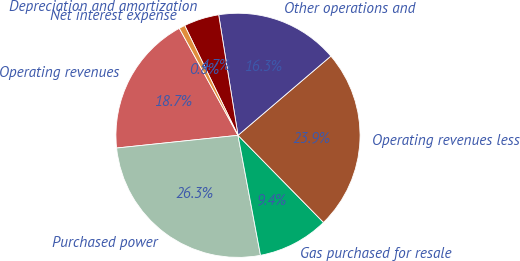Convert chart to OTSL. <chart><loc_0><loc_0><loc_500><loc_500><pie_chart><fcel>Operating revenues<fcel>Purchased power<fcel>Gas purchased for resale<fcel>Operating revenues less<fcel>Other operations and<fcel>Depreciation and amortization<fcel>Net interest expense<nl><fcel>18.68%<fcel>26.29%<fcel>9.4%<fcel>23.89%<fcel>16.29%<fcel>4.66%<fcel>0.79%<nl></chart> 